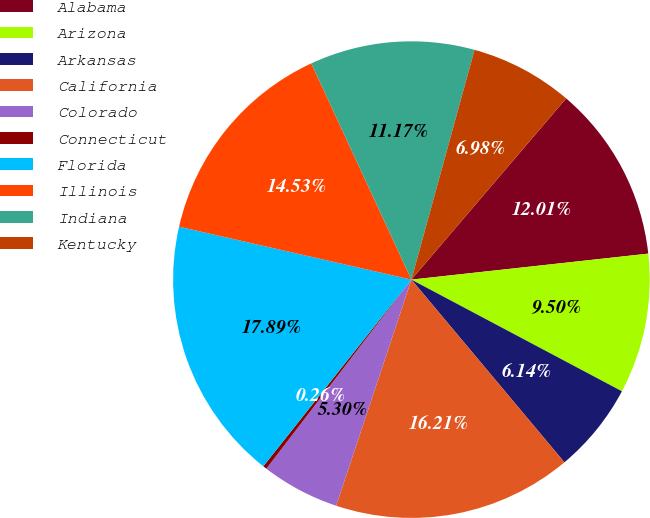<chart> <loc_0><loc_0><loc_500><loc_500><pie_chart><fcel>Alabama<fcel>Arizona<fcel>Arkansas<fcel>California<fcel>Colorado<fcel>Connecticut<fcel>Florida<fcel>Illinois<fcel>Indiana<fcel>Kentucky<nl><fcel>12.01%<fcel>9.5%<fcel>6.14%<fcel>16.21%<fcel>5.3%<fcel>0.26%<fcel>17.89%<fcel>14.53%<fcel>11.17%<fcel>6.98%<nl></chart> 